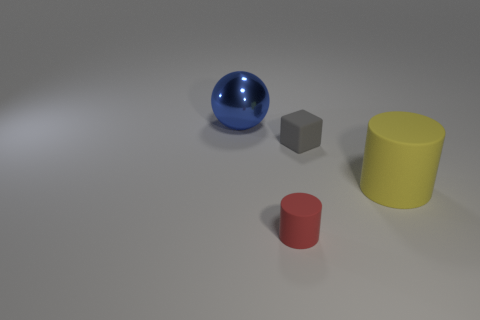Add 2 blue spheres. How many objects exist? 6 Subtract all blocks. How many objects are left? 3 Subtract 0 gray cylinders. How many objects are left? 4 Subtract all big brown metallic balls. Subtract all spheres. How many objects are left? 3 Add 4 gray blocks. How many gray blocks are left? 5 Add 4 green blocks. How many green blocks exist? 4 